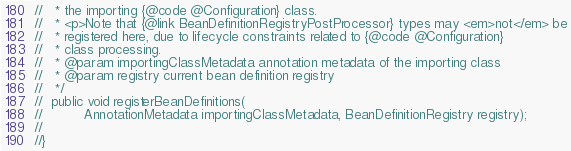Convert code to text. <code><loc_0><loc_0><loc_500><loc_500><_Java_>//	 * the importing {@code @Configuration} class.
//	 * <p>Note that {@link BeanDefinitionRegistryPostProcessor} types may <em>not</em> be
//	 * registered here, due to lifecycle constraints related to {@code @Configuration}
//	 * class processing.
//	 * @param importingClassMetadata annotation metadata of the importing class
//	 * @param registry current bean definition registry
//	 */
//	public void registerBeanDefinitions(
//			AnnotationMetadata importingClassMetadata, BeanDefinitionRegistry registry);
//
//}</code> 